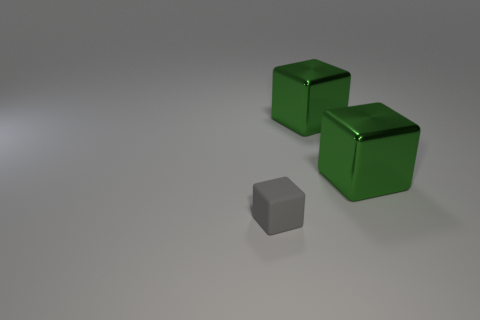What number of objects are either things that are on the right side of the tiny thing or small matte things?
Your answer should be very brief. 3. What number of other objects are the same shape as the small gray object?
Ensure brevity in your answer.  2. Are there any tiny objects right of the gray thing?
Offer a terse response. No. What number of tiny things are either blocks or green cubes?
Provide a short and direct response. 1. Is there a metal thing that has the same color as the small rubber cube?
Keep it short and to the point. No. The tiny block is what color?
Make the answer very short. Gray. Are there any gray shiny blocks of the same size as the gray rubber object?
Make the answer very short. No. How many big green metal things are the same shape as the small thing?
Provide a succinct answer. 2. The gray matte thing is what shape?
Your response must be concise. Cube. Is the number of small blocks in front of the small cube the same as the number of balls?
Your answer should be compact. Yes. 